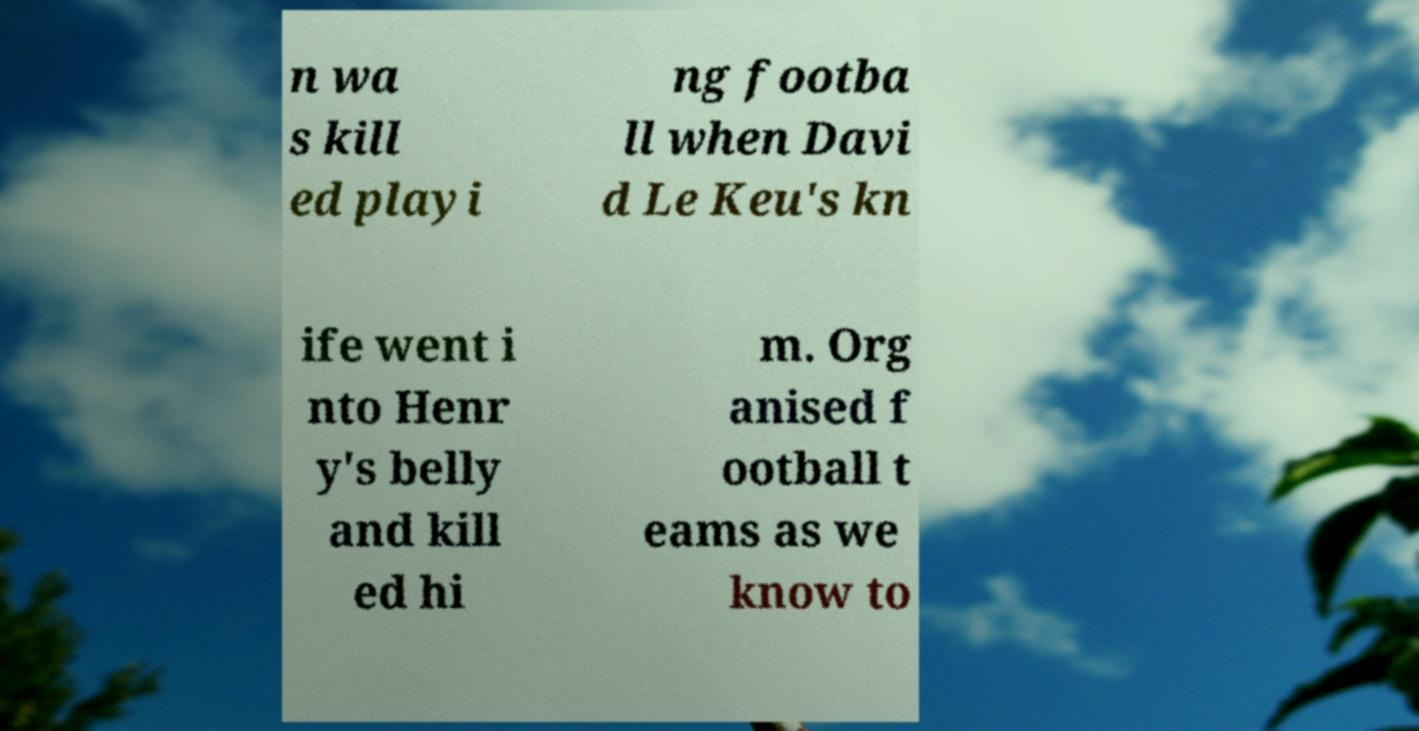Please read and relay the text visible in this image. What does it say? n wa s kill ed playi ng footba ll when Davi d Le Keu's kn ife went i nto Henr y's belly and kill ed hi m. Org anised f ootball t eams as we know to 